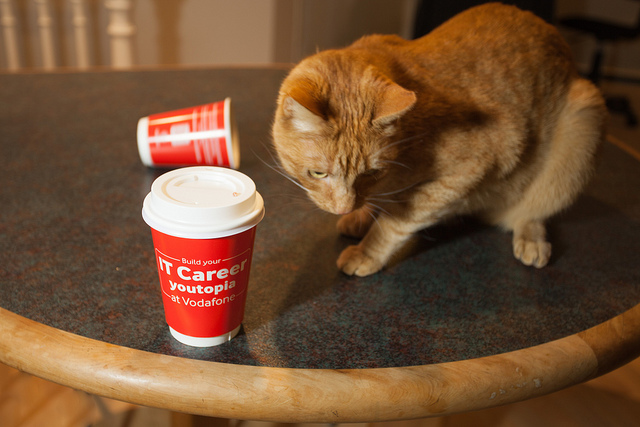<image>Is the cat trying to catch a mouse? I don't know if the cat is trying to catch a mouse. Is the cat trying to catch a mouse? I am not sure if the cat is trying to catch a mouse. It can be seen both 'no' and 'maybe'. 